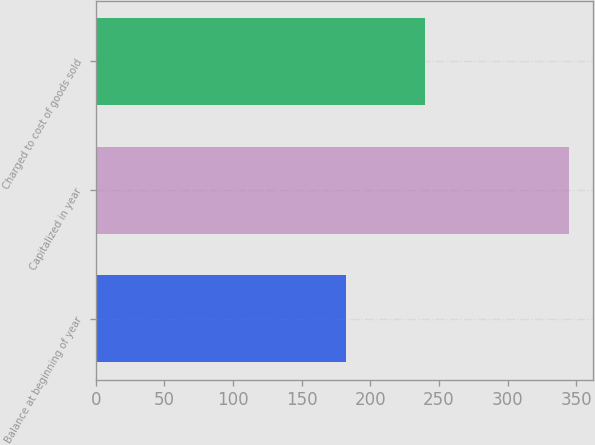<chart> <loc_0><loc_0><loc_500><loc_500><bar_chart><fcel>Balance at beginning of year<fcel>Capitalized in year<fcel>Charged to cost of goods sold<nl><fcel>182<fcel>345<fcel>240<nl></chart> 